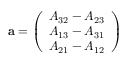<formula> <loc_0><loc_0><loc_500><loc_500>a = { \left ( \begin{array} { l } { A _ { 3 2 } - A _ { 2 3 } } \\ { A _ { 1 3 } - A _ { 3 1 } } \\ { A _ { 2 1 } - A _ { 1 2 } } \end{array} \right ) }</formula> 